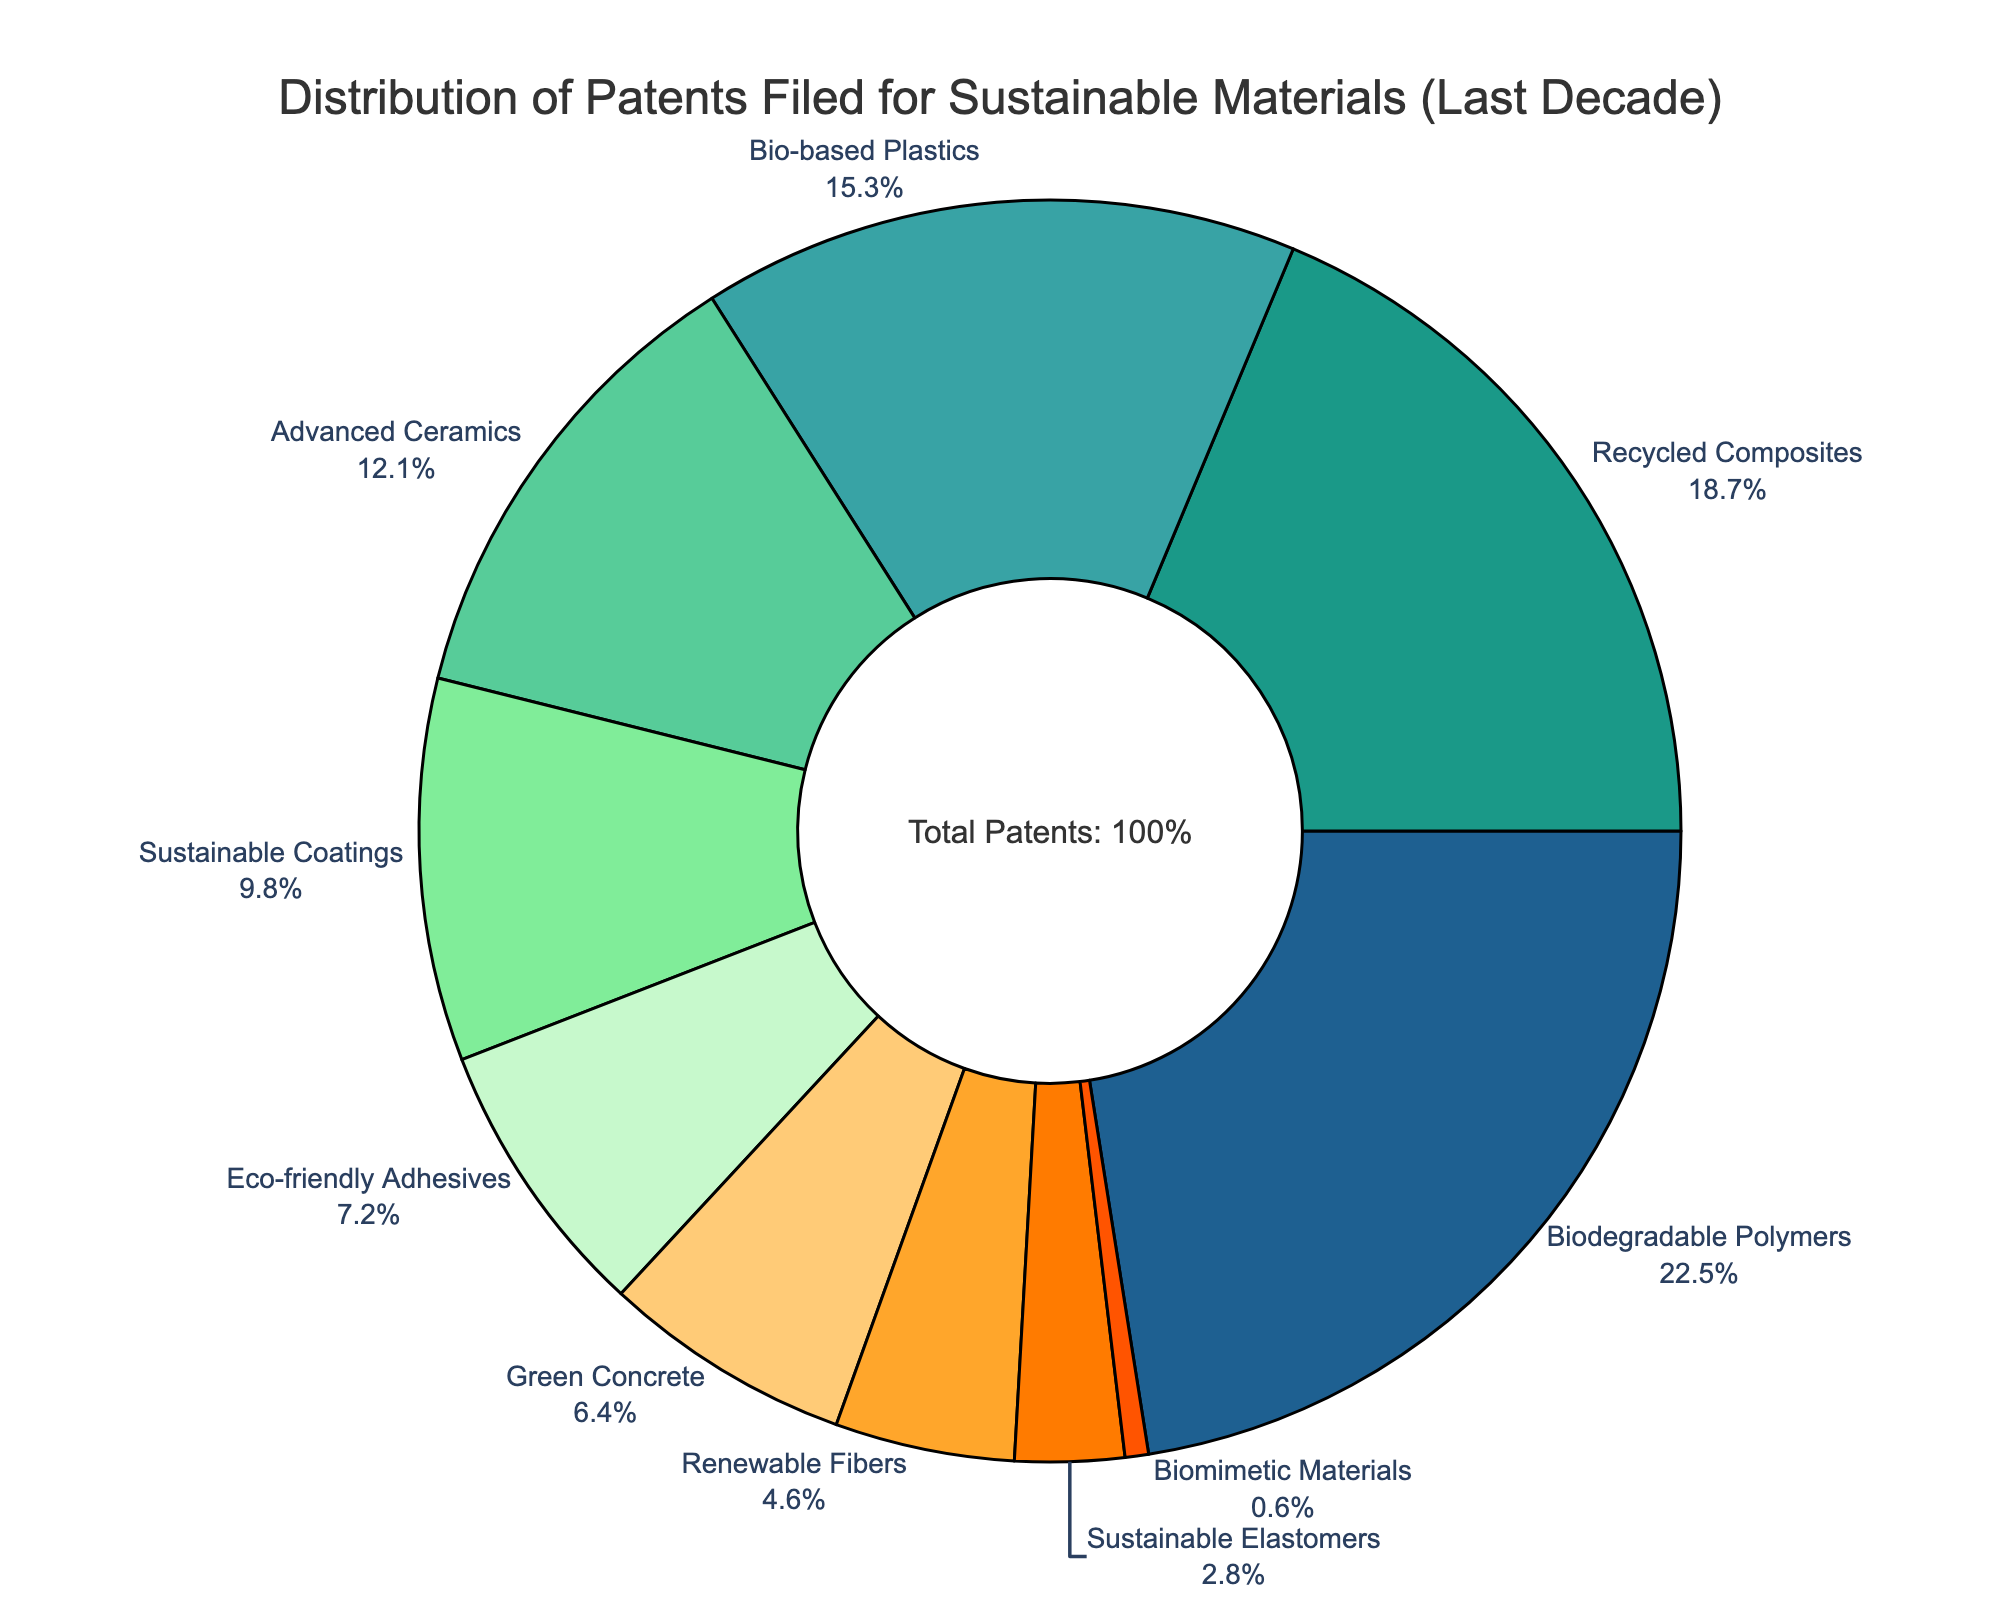Which category holds the highest percentage of patents filed? To determine the category with the highest percentage, look at the segment size of each category in the pie chart. The "Biodegradable Polymers" section is the largest.
Answer: Biodegradable Polymers What is the combined percentage of patents for Bio-based Plastics and Recycled Composites? Add the percentages for Bio-based Plastics (15.3%) and Recycled Composites (18.7%). The sum is 15.3% + 18.7% = 34.0%.
Answer: 34.0% Which category has the smallest share of patents? Look for the smallest segment in the pie chart. "Biomimetic Materials" has the smallest segment.
Answer: Biomimetic Materials How much larger is the percentage of Biodegradable Polymers compared to Green Concrete? Subtract the percentage of Green Concrete (6.4%) from Biodegradable Polymers (22.5%). The result is 22.5% - 6.4% = 16.1%.
Answer: 16.1% What percentage of patents are associated with Sustainable Coatings, Eco-friendly Adhesives, and Sustainable Elastomers combined? Add the percentages for Sustainable Coatings (9.8%), Eco-friendly Adhesives (7.2%), and Sustainable Elastomers (2.8%). The sum is 9.8% + 7.2% + 2.8% = 19.8%.
Answer: 19.8% Which segments are represented in shades of green? Identify the segments in green shades. The segments for Biodegradable Polymers, Recycled Composites, Bio-based Plastics, Advanced Ceramics, Sustainable Coatings, Eco-friendly Adhesives, and Green Concrete are in shades of green.
Answer: Biodegradable Polymers, Recycled Composites, Bio-based Plastics, Advanced Ceramics, Sustainable Coatings, Eco-friendly Adhesives, Green Concrete Is the percentage of Green Concrete patents larger or smaller than Sustainable Elastomers? Compare the segment sizes of Green Concrete (6.4%) and Sustainable Elastomers (2.8%). Green Concrete has a larger segment.
Answer: Larger What is the total percentage of patents for categories related to plastics (Bio-based Plastics and Biodegradable Polymers)? Add the percentages for Bio-based Plastics (15.3%) and Biodegradable Polymers (22.5%). The sum is 15.3% + 22.5% = 37.8%.
Answer: 37.8% Does the percentage of patents for Advanced Ceramics exceed that of Eco-friendly Adhesives? Compare the percentages of Advanced Ceramics (12.1%) and Eco-friendly Adhesives (7.2%). Advanced Ceramics has a larger percentage.
Answer: Yes 